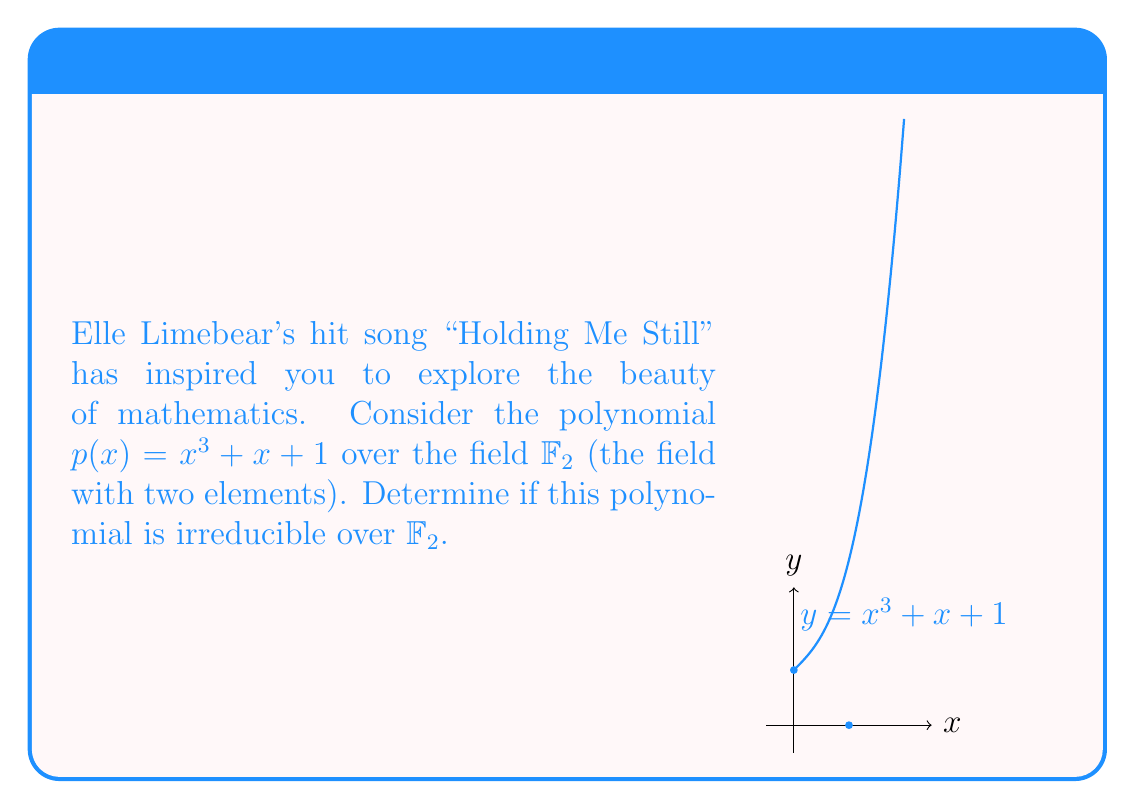Can you answer this question? To determine if $p(x) = x^3 + x + 1$ is irreducible over $\mathbb{F}_2$, we'll follow these steps:

1) First, recall that in $\mathbb{F}_2$, $1 + 1 = 0$, and all other arithmetic is performed modulo 2.

2) A cubic polynomial over a field is reducible if and only if it has a root in that field.

3) In $\mathbb{F}_2$, there are only two elements: 0 and 1. We need to check if either of these is a root of $p(x)$.

4) For $x = 0$:
   $p(0) = 0^3 + 0 + 1 = 1 \neq 0$

5) For $x = 1$:
   $p(1) = 1^3 + 1 + 1 = 1 + 1 + 1 = 1 \neq 0$

6) Since neither 0 nor 1 is a root of $p(x)$, the polynomial has no roots in $\mathbb{F}_2$.

7) Therefore, $p(x) = x^3 + x + 1$ is irreducible over $\mathbb{F}_2$.

This result shows that, like the harmonious complexity in Elle Limebear's music, even simple-looking polynomials can have profound mathematical properties.
Answer: Irreducible over $\mathbb{F}_2$ 